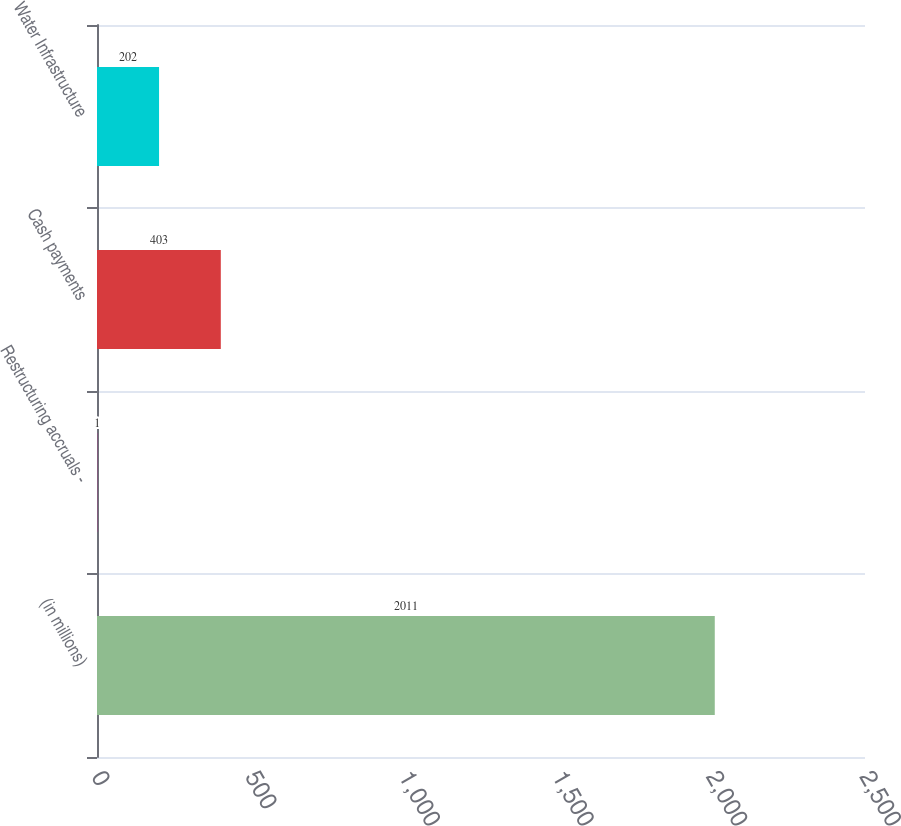Convert chart to OTSL. <chart><loc_0><loc_0><loc_500><loc_500><bar_chart><fcel>(in millions)<fcel>Restructuring accruals -<fcel>Cash payments<fcel>Water Infrastructure<nl><fcel>2011<fcel>1<fcel>403<fcel>202<nl></chart> 